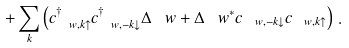<formula> <loc_0><loc_0><loc_500><loc_500>+ \sum _ { k } \left ( c ^ { \dagger } _ { \ w , { k } \uparrow } c ^ { \dagger } _ { \ w , - { k } \downarrow } \Delta _ { \ } w + \Delta _ { \ } w ^ { \ast } c _ { \ w , - { k } \downarrow } c _ { \ w , { k } \uparrow } \right ) \, .</formula> 